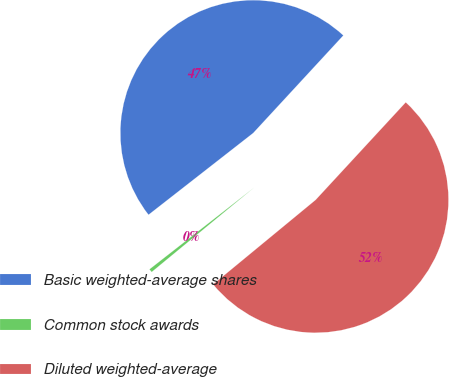<chart> <loc_0><loc_0><loc_500><loc_500><pie_chart><fcel>Basic weighted-average shares<fcel>Common stock awards<fcel>Diluted weighted-average<nl><fcel>47.42%<fcel>0.42%<fcel>52.16%<nl></chart> 